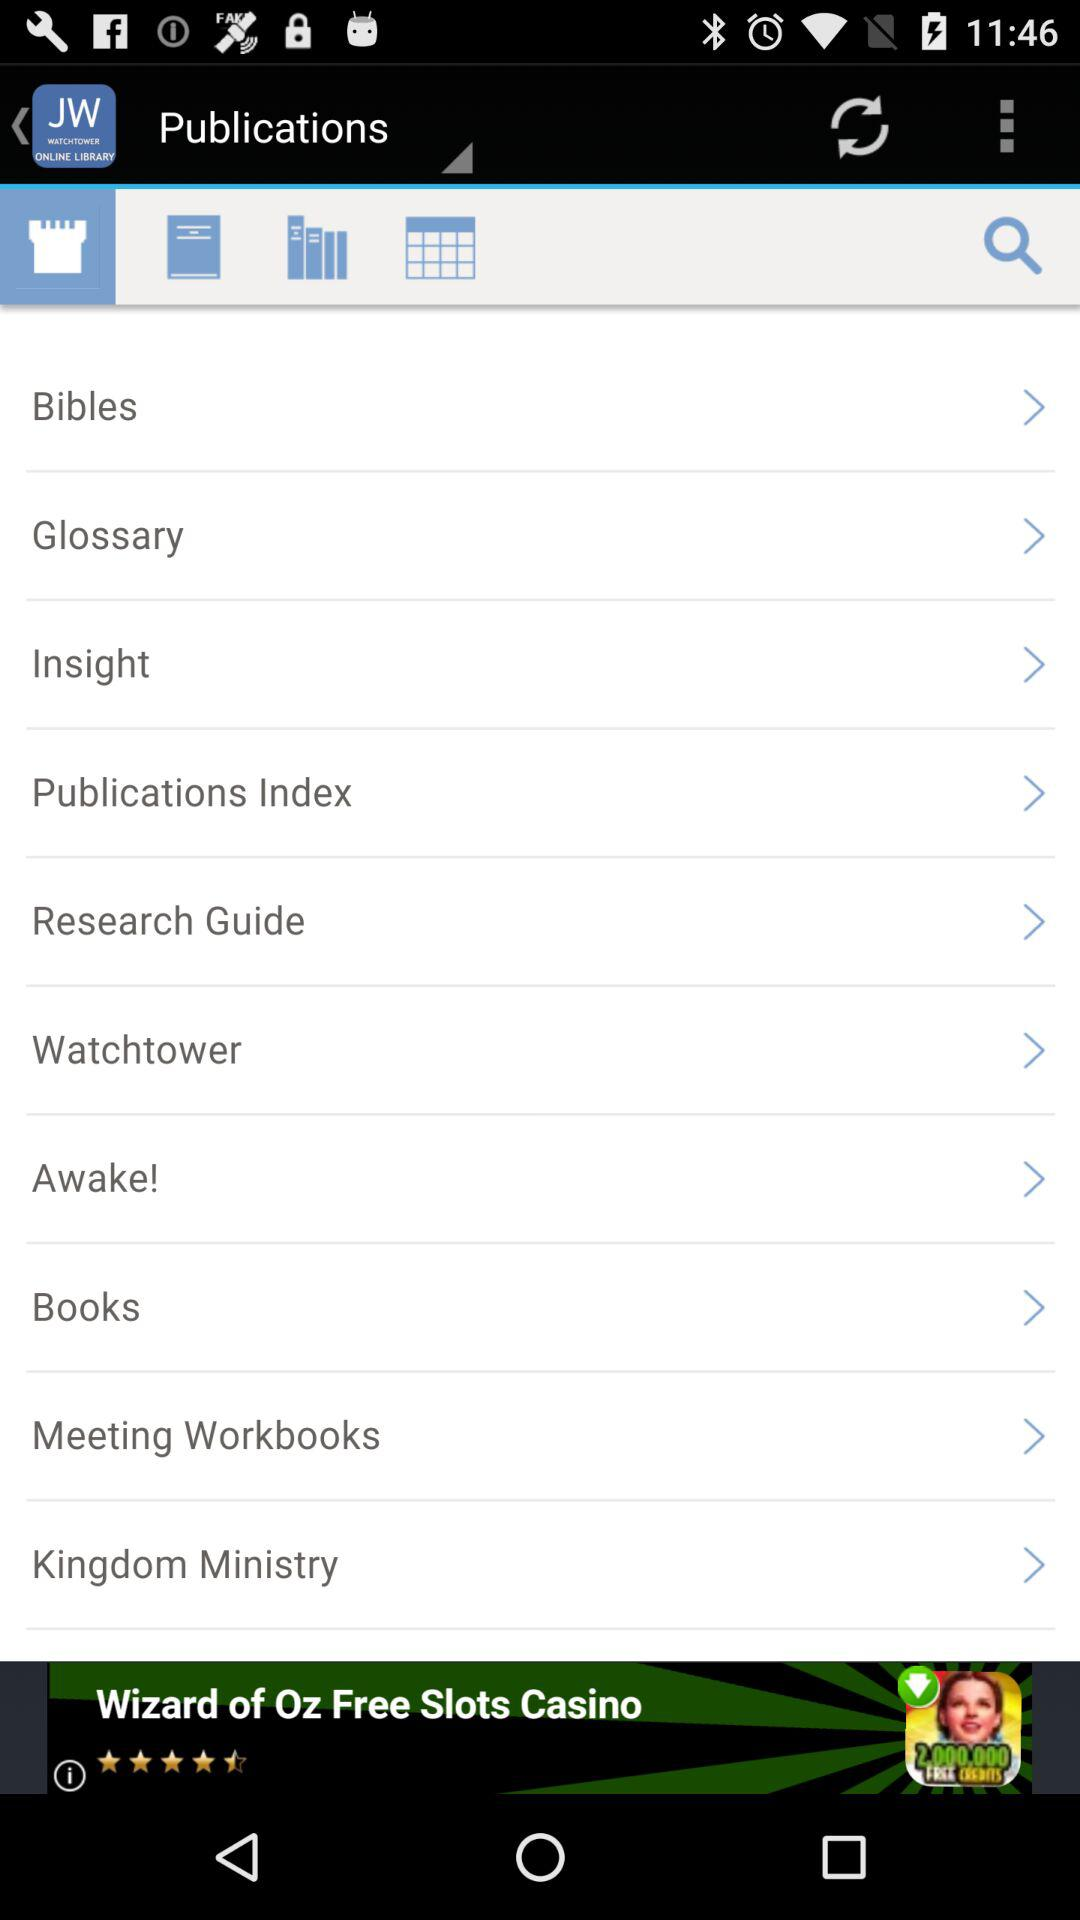What is the app name? The app name is "Watchtower Online Library". 